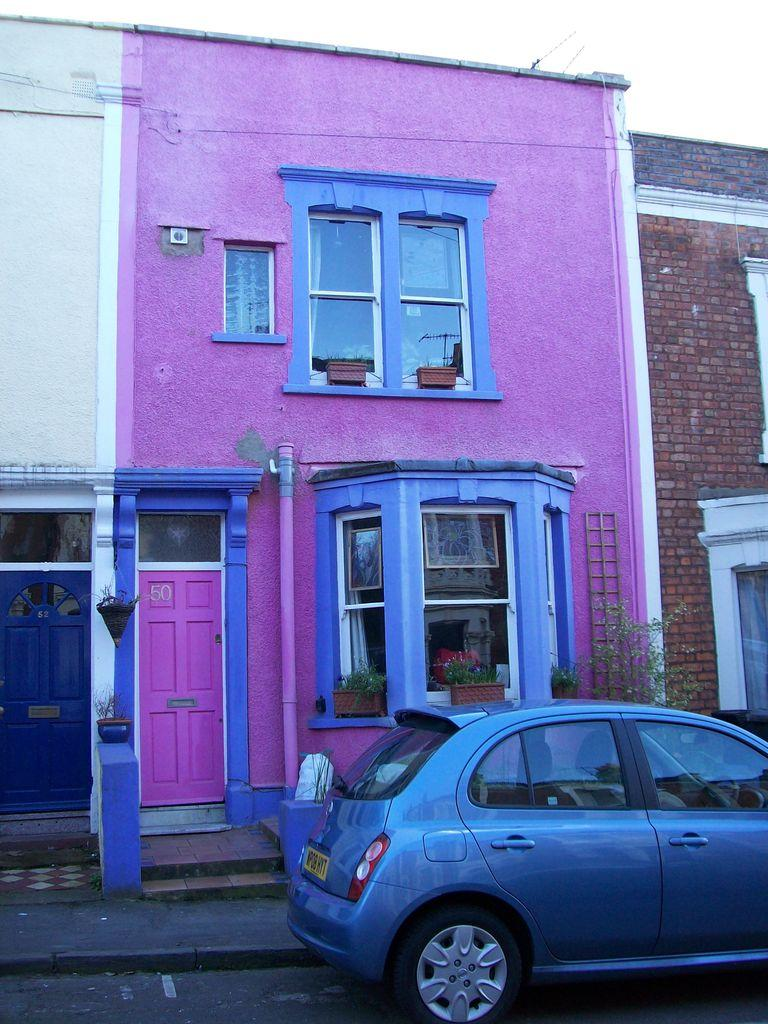What is the main subject of the image? There is a vehicle on the road in the image. What can be seen in the distance behind the vehicle? There are buildings and house plants in the background of the image. Are there any other objects visible in the background? Yes, there are some objects visible in the background of the image. What type of industry is being controlled by the vehicle in the image? There is no indication of any industry or control in the image; it simply shows a vehicle on the road and the background. 